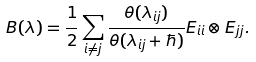<formula> <loc_0><loc_0><loc_500><loc_500>B ( \lambda ) = \frac { 1 } { 2 } \sum _ { i \ne j } \frac { \theta ( \lambda _ { i j } ) } { \theta ( \lambda _ { i j } + \hbar { ) } } E _ { i i } \otimes E _ { j j } .</formula> 